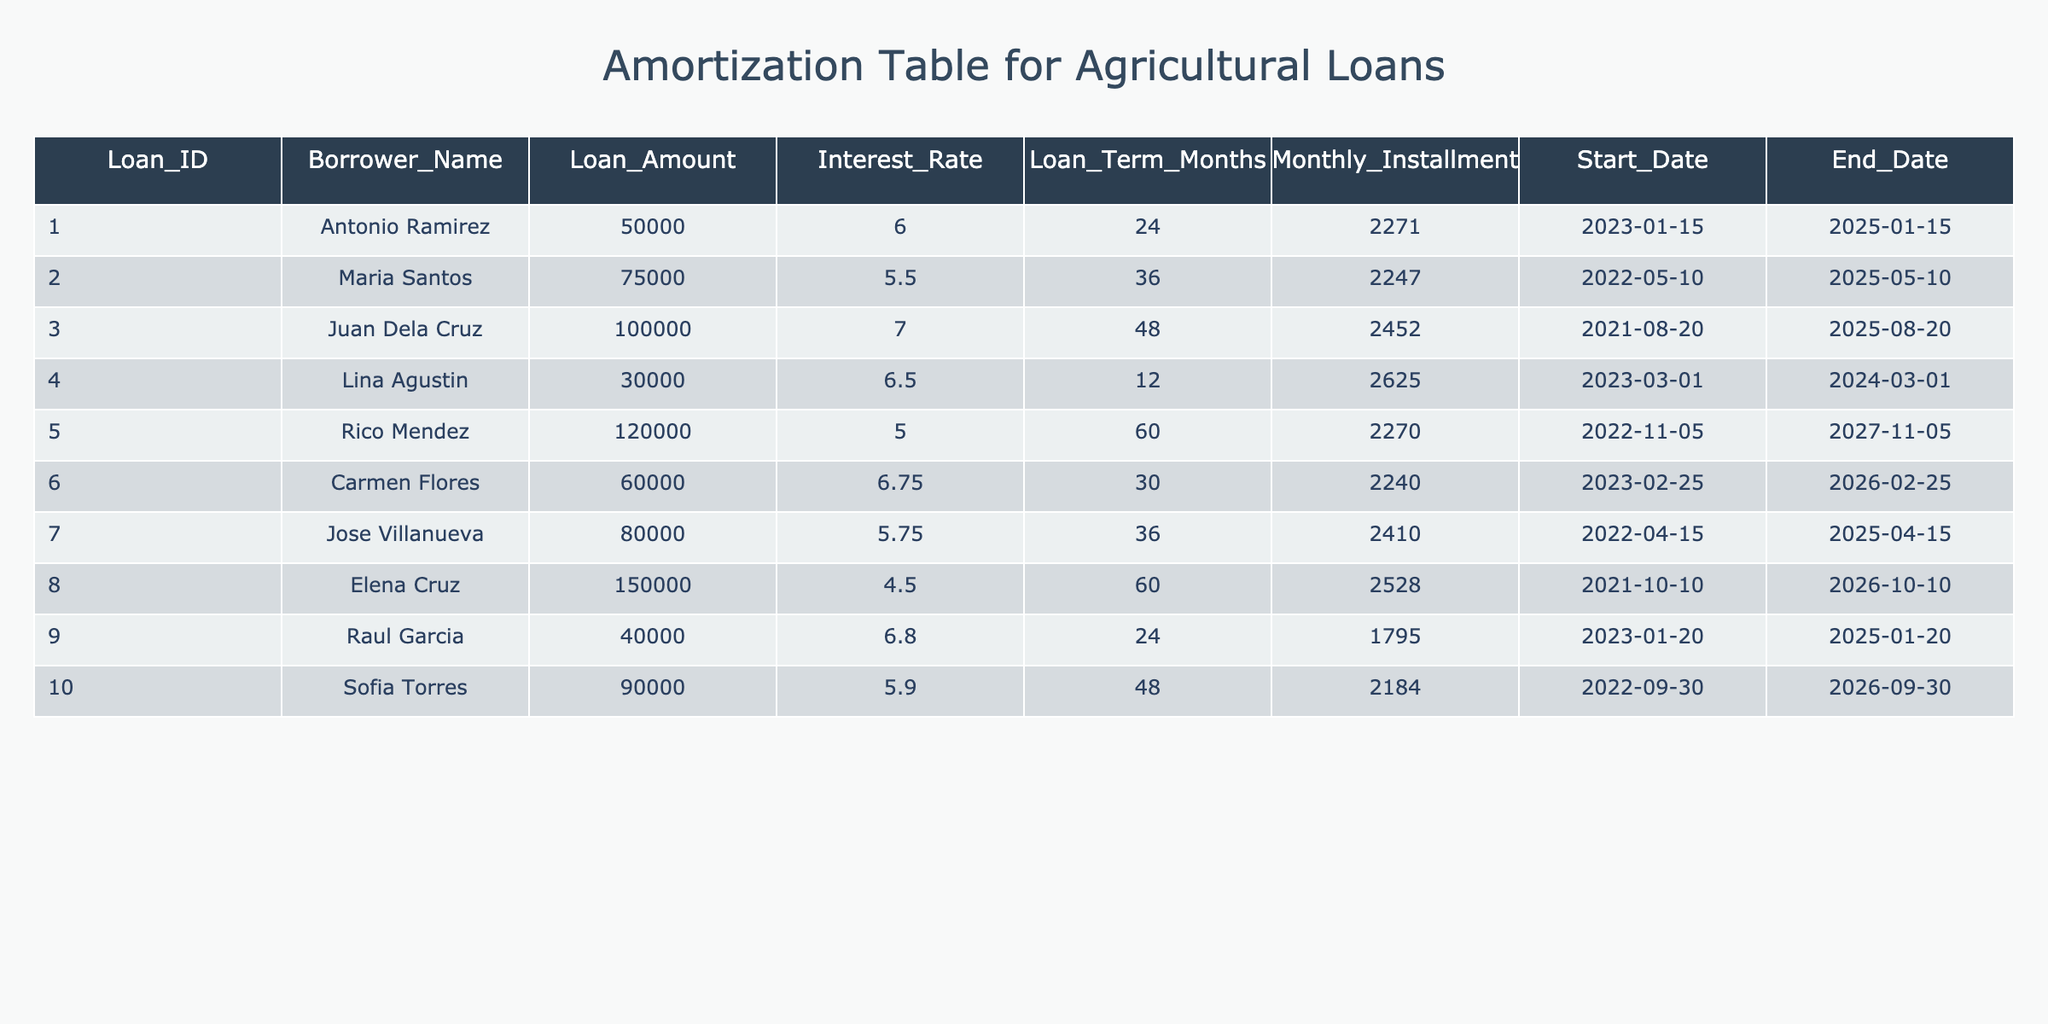What is the total loan amount given to all borrowers? To find the total loan amount, we need to sum the loan amounts from all rows in the table. The loan amounts are 50000, 75000, 100000, 30000, 120000, 60000, 80000, 150000, 40000, and 90000. The total loan amount is calculated as follows: 50000 + 75000 + 100000 + 30000 + 120000 + 60000 + 80000 + 150000 + 40000 + 90000 = 720000.
Answer: 720000 Which borrower has the highest monthly installment? Looking at the 'Monthly Installment' column, we compare the values for each borrower. The maximum value is 2625.00, which corresponds to Lina Agustin.
Answer: Lina Agustin What is the average interest rate of the loans? To calculate the average interest rate, we sum all the interest rates (6.00, 5.50, 7.00, 6.50, 5.00, 6.75, 5.75, 4.50, 6.80, 5.90) which totals to 60.70, and then divide by the number of loans (10): 60.70 / 10 = 6.07.
Answer: 6.07 Is there a loan with an interest rate lower than 5%? By examining the 'Interest Rate' column, we see that the minimum interest rate is 4.50 for Elena Cruz. Therefore, it is true that there is a loan lower than 5%.
Answer: Yes Which loan ID corresponds to a loan term of 60 months? We can scan through the 'Loan Term Months' column to find which entry equals 60. The loan IDs 005 and 008 both have a term of 60 months.
Answer: 005, 008 What is the difference in loan amount between the highest and lowest loans? The highest loan amount is 150000 (Elena Cruz) and the lowest is 30000 (Lina Agustin). The difference is calculated as 150000 - 30000 = 120000.
Answer: 120000 How many borrowers have a loan amount greater than 70000? By checking the 'Loan Amount' column, we find the borrowers with amounts greater than 70000: Maria Santos, Juan Dela Cruz, Rico Mendez, Jose Villanueva, Elena Cruz, and Sofia Torres. This gives us a total of 6 borrowers.
Answer: 6 What percentage of the total loan amount does Antonio Ramirez's loan represent? Antonio Ramirez's loan amount is 50000. The total loan amount is 720000. The percentage is calculated as (50000 / 720000) * 100 = 6.94%.
Answer: 6.94% How many loans have an end date in 2026? Checking the 'End Date' column, the loans that end in 2026 are from borrowers with Loan IDs 006, 008, and 010. This gives us a count of 3 loans.
Answer: 3 